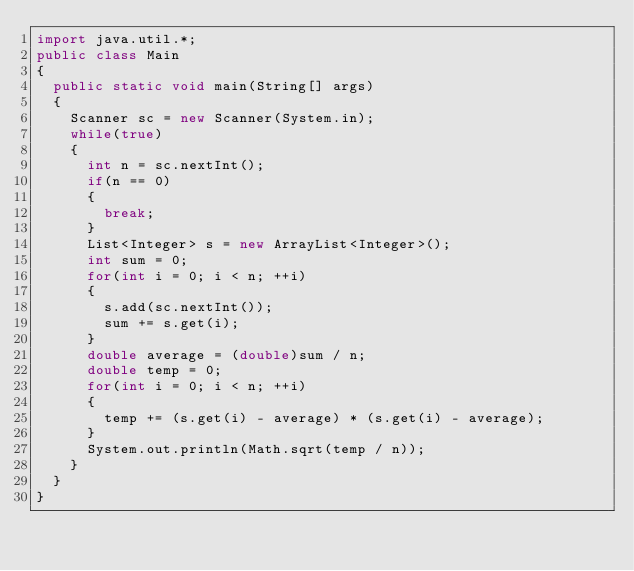<code> <loc_0><loc_0><loc_500><loc_500><_Java_>import java.util.*;
public class Main 
{
	public static void main(String[] args) 
	{	
		Scanner sc = new Scanner(System.in);
		while(true)
		{
			int n = sc.nextInt();
			if(n == 0)
			{
				break;
			}
			List<Integer> s = new ArrayList<Integer>();
			int sum = 0;
			for(int i = 0; i < n; ++i)
			{
				s.add(sc.nextInt());
				sum += s.get(i);
			}
			double average = (double)sum / n;
			double temp = 0;
			for(int i = 0; i < n; ++i)
			{
				temp += (s.get(i) - average) * (s.get(i) - average);
			}
			System.out.println(Math.sqrt(temp / n));
		}
	}
}</code> 